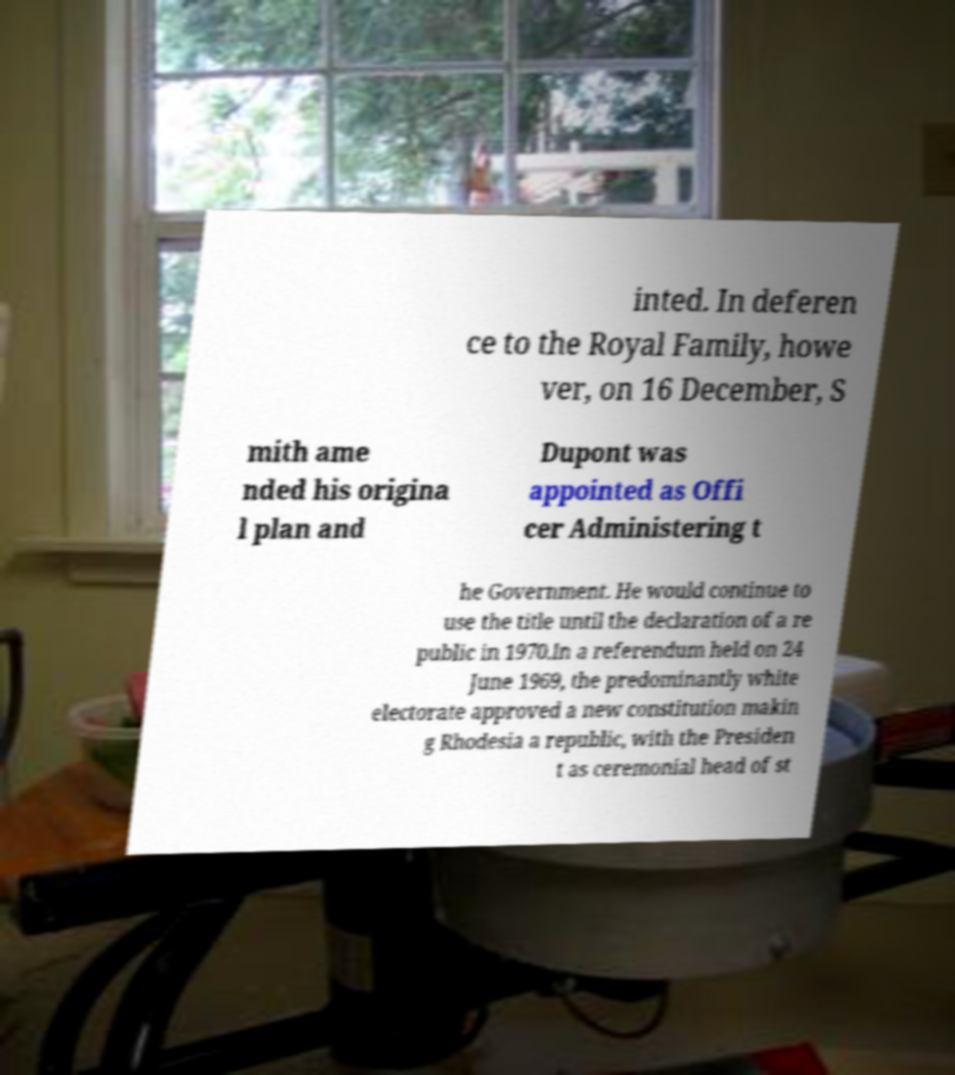Can you accurately transcribe the text from the provided image for me? inted. In deferen ce to the Royal Family, howe ver, on 16 December, S mith ame nded his origina l plan and Dupont was appointed as Offi cer Administering t he Government. He would continue to use the title until the declaration of a re public in 1970.In a referendum held on 24 June 1969, the predominantly white electorate approved a new constitution makin g Rhodesia a republic, with the Presiden t as ceremonial head of st 